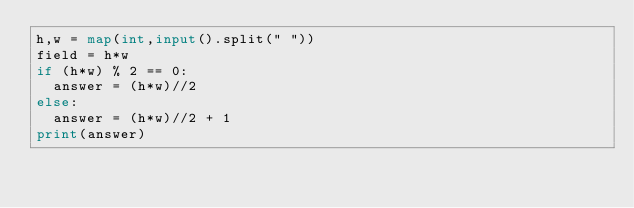Convert code to text. <code><loc_0><loc_0><loc_500><loc_500><_Python_>h,w = map(int,input().split(" "))
field = h*w
if (h*w) % 2 == 0:
  answer = (h*w)//2
else:
  answer = (h*w)//2 + 1
print(answer)</code> 